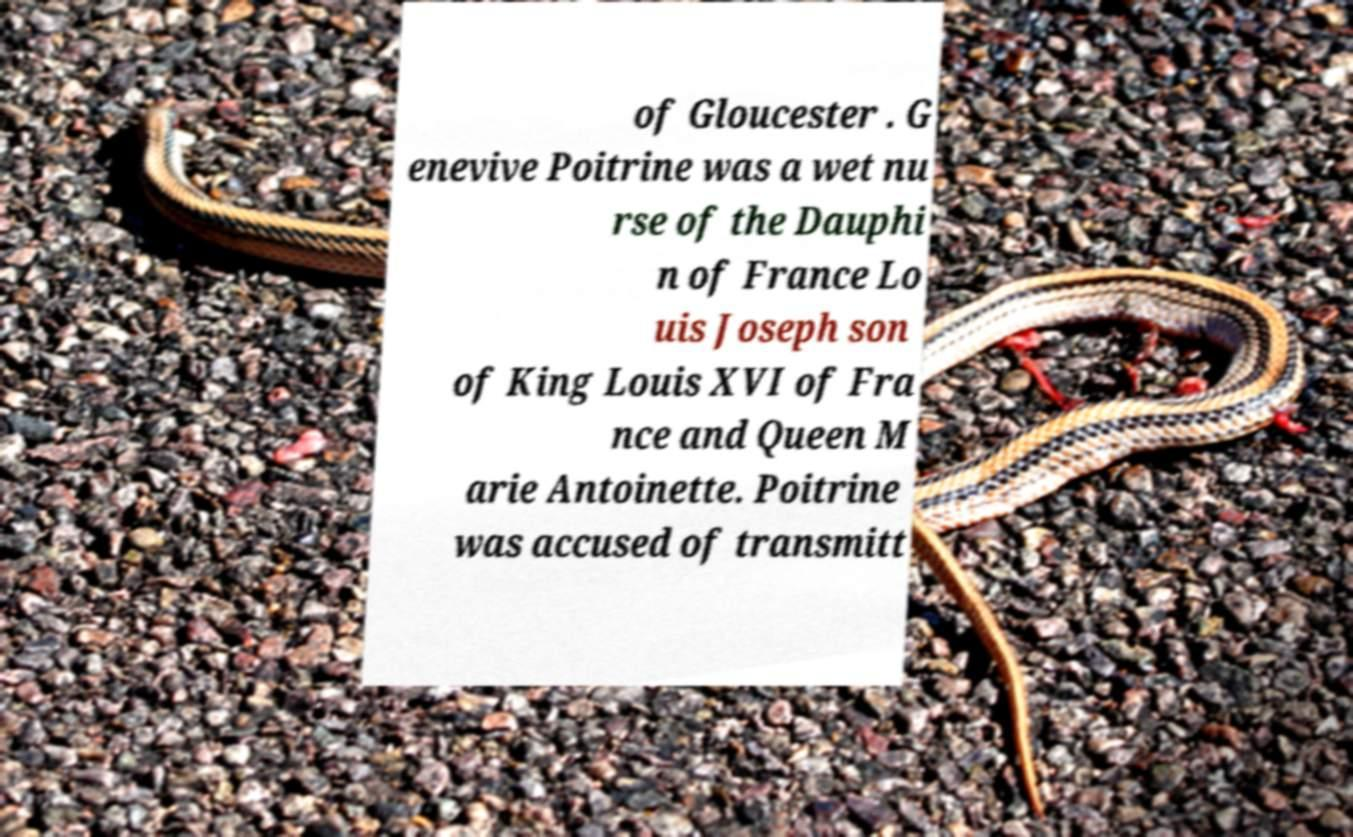Please read and relay the text visible in this image. What does it say? of Gloucester . G enevive Poitrine was a wet nu rse of the Dauphi n of France Lo uis Joseph son of King Louis XVI of Fra nce and Queen M arie Antoinette. Poitrine was accused of transmitt 